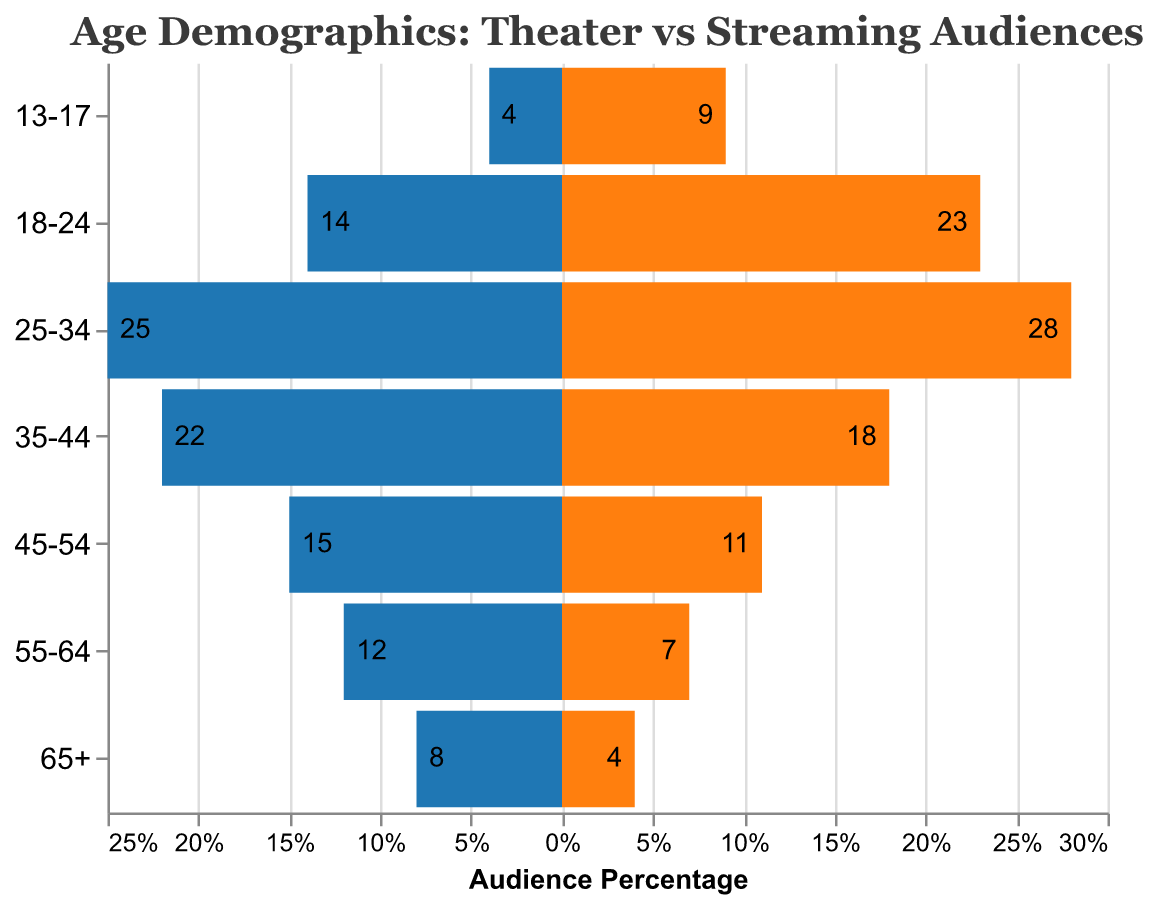What's the title of the figure? The title of the figure is usually written at the top. For this figure, it's "Age Demographics: Theater vs Streaming Audiences" as mentioned in the code.
Answer: Age Demographics: Theater vs Streaming Audiences Which age group has the highest percentage of theater audiences? The data provides different percentages for various age groups, and we need to identify the highest one. The highest value for theater audiences is 25% for the 25-34 age group.
Answer: 25-34 Compare the theater audience percentages between the age groups 18-24 and 35-44. Which one is higher? By referring to the figure, the theater audience for 18-24 is 14%, while for 35-44 it is 22%. So, 35-44 is higher.
Answer: 35-44 In general, do younger or older age groups prefer streaming services more than theaters? By examining the figure, younger age groups (13-17, 18-24) have higher percentages of streaming service users compared to their theater audience percentages. For instance, the 18-24 age group has a significantly higher percentage of streaming users (23%) than theater audiences (14%).
Answer: Younger What is the difference in streaming service users between the 25-34 and 55-64 age groups? The percentage for 25-34 in streaming services is 28%, and for 55-64 it is 7%. The difference is calculated by subtracting the smaller value from the larger one: 28% - 7% = 21%.
Answer: 21% Which age group has the smallest difference between theater audience and streaming service users? We need to compare the differences for each age group. For instance, age group 35-44 has theater 22% and streaming 18%, which yields a difference of 4%. This is the smallest difference among all age groups.
Answer: 35-44 For both theater audiences and streaming service users, identify the age group with the lowest percentage. For theater audiences, the lowest percentage is 4% for the 13-17 age group. For streaming service users, it is 4% for the 65+ age group.
Answer: Theater: 13-17; Streaming: 65+ How do the percentages compare between the 45-54 and 55-64 age groups for both theaters and streaming services? For theaters: 45-54: 15%, 55-64: 12%. For streaming: 45-54: 11%, 55-64: 7%. In both categories, 45-54 has higher percentages than 55-64.
Answer: 45-54 > 55-64 What is the total percentage of streaming service users for the 18-24 and 25-34 age groups combined? Adding the percentages for these two age groups: 18-24 (23%) and 25-34 (28%). The total is 23% + 28% = 51%.
Answer: 51% 